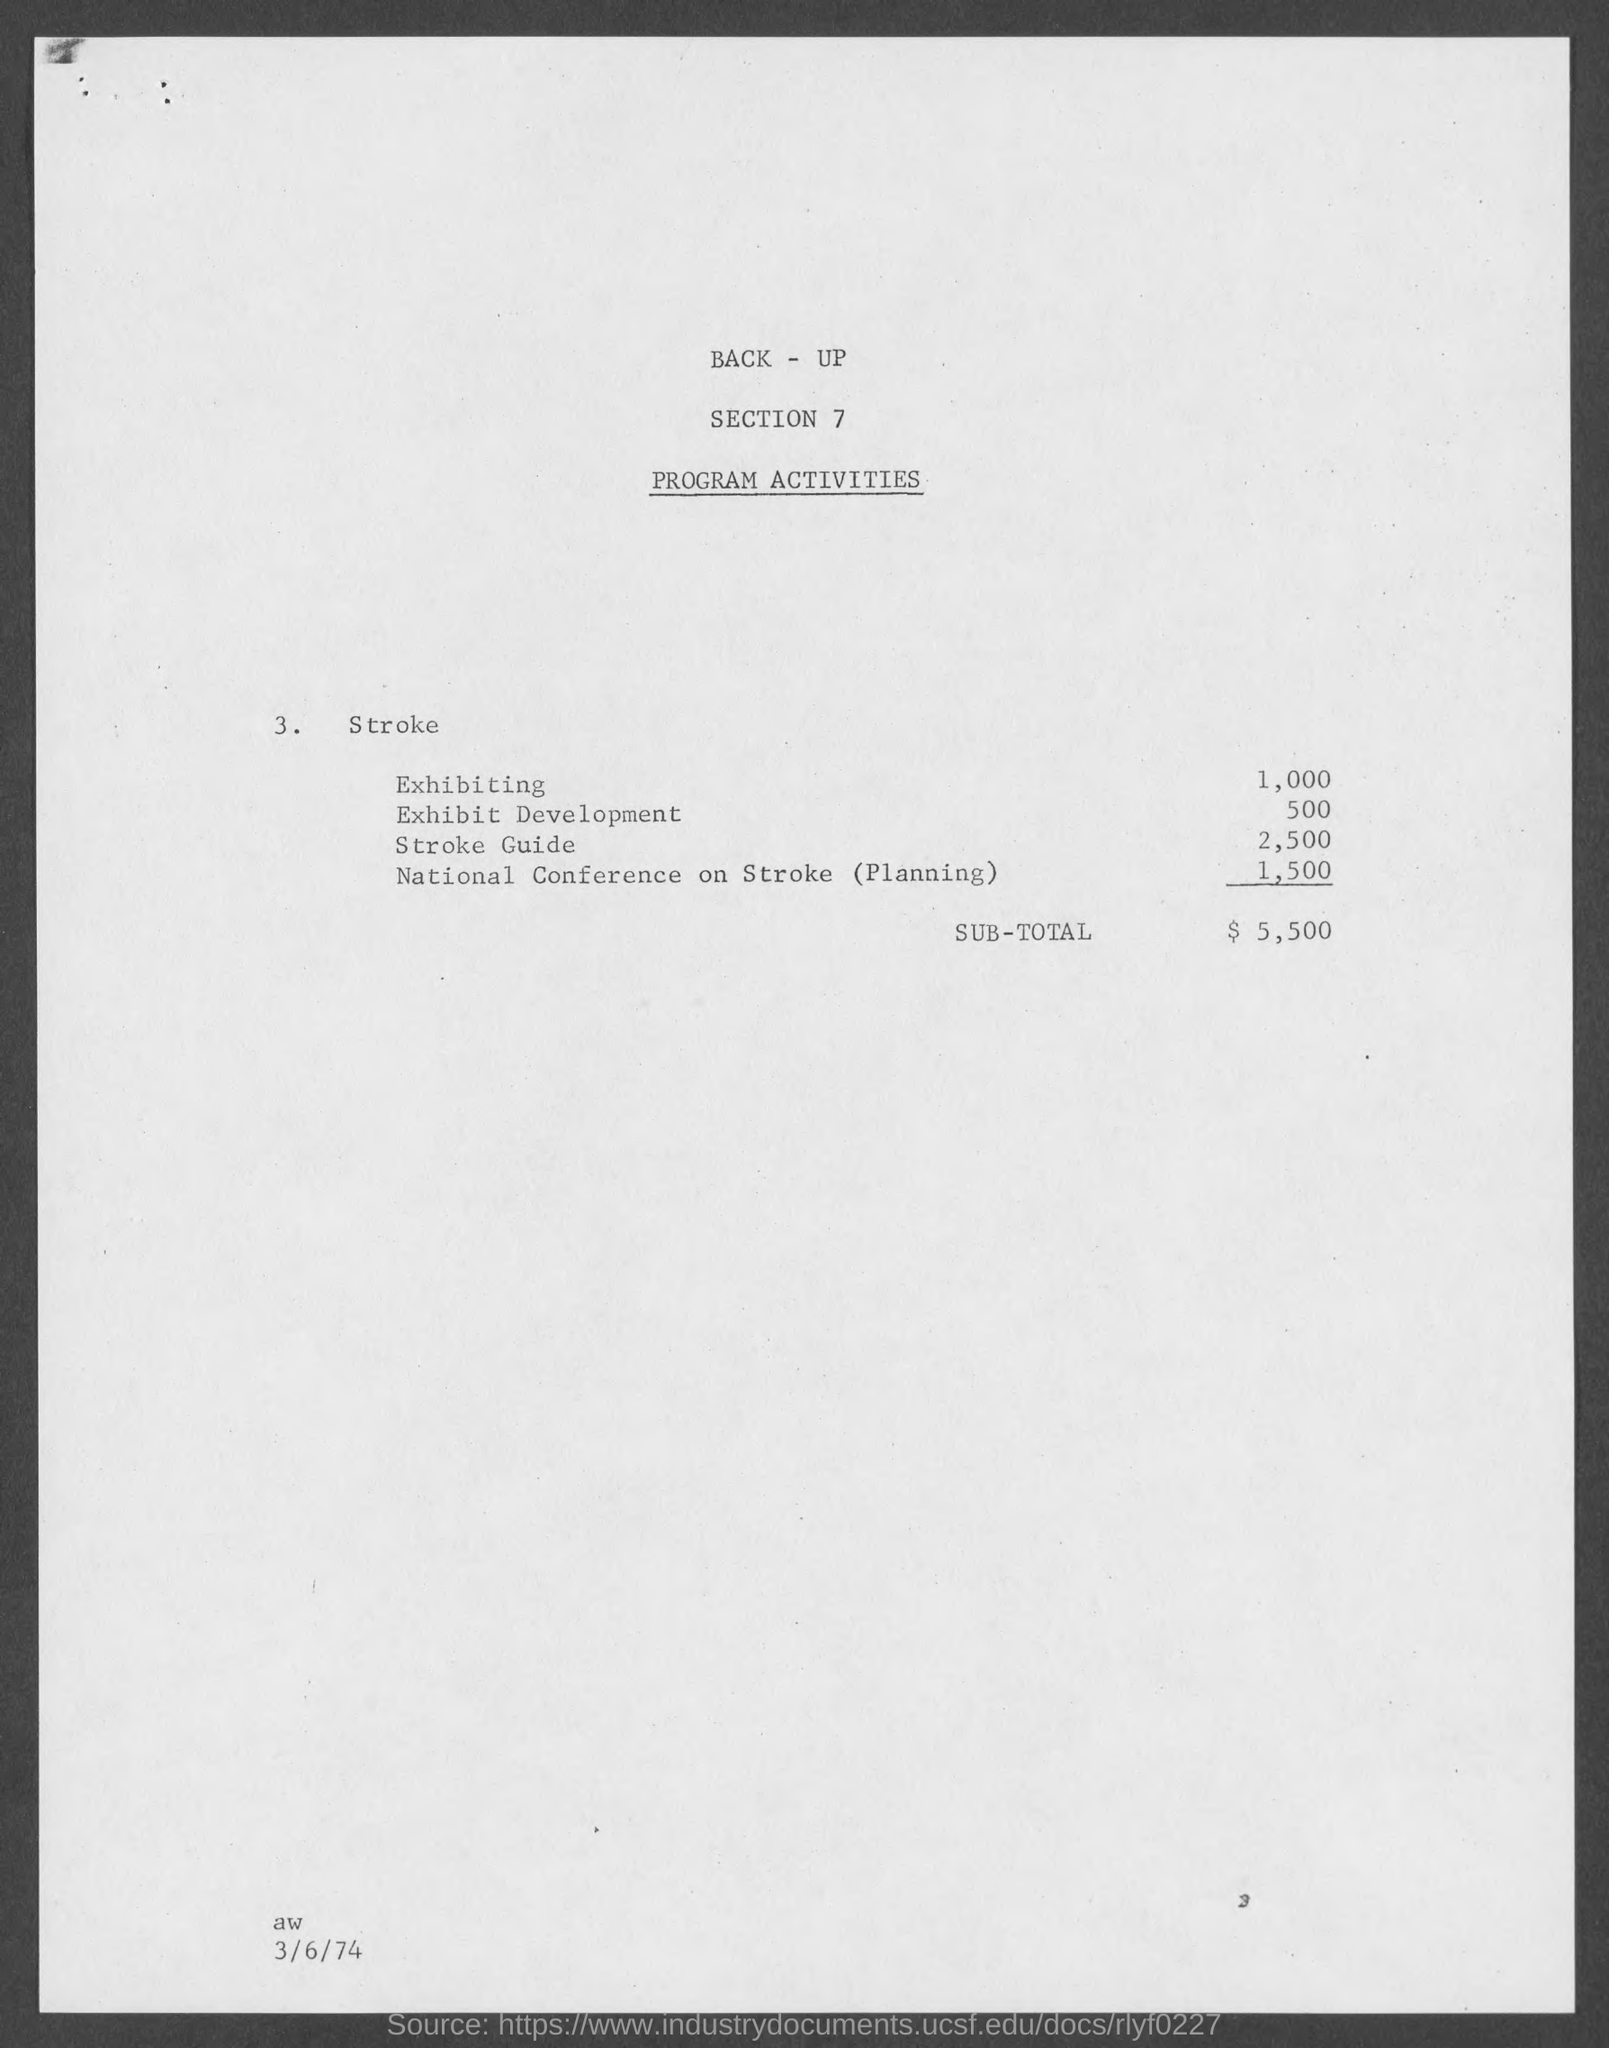Point out several critical features in this image. The SUB-TOTAL amount is $5,500. The amount corresponding to the Stroke Guide is 2,500. The section mentioned is section 7. 